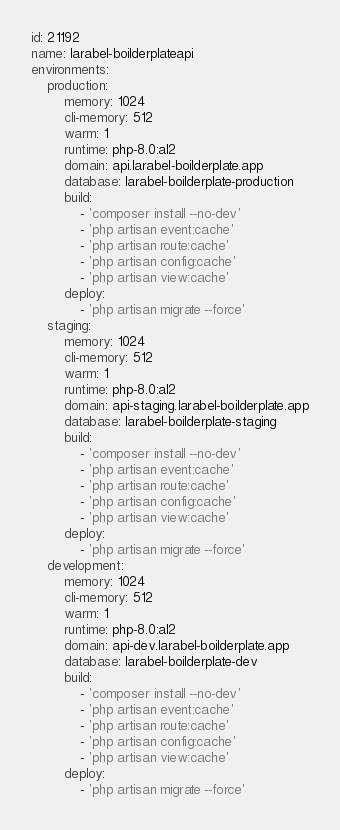<code> <loc_0><loc_0><loc_500><loc_500><_YAML_>id: 21192
name: larabel-boilderplateapi
environments:
    production:
        memory: 1024
        cli-memory: 512
        warm: 1
        runtime: php-8.0:al2
        domain: api.larabel-boilderplate.app
        database: larabel-boilderplate-production
        build:
            - 'composer install --no-dev'
            - 'php artisan event:cache'
            - 'php artisan route:cache'
            - 'php artisan config:cache'
            - 'php artisan view:cache'
        deploy:
            - 'php artisan migrate --force'
    staging:
        memory: 1024
        cli-memory: 512
        warm: 1
        runtime: php-8.0:al2
        domain: api-staging.larabel-boilderplate.app
        database: larabel-boilderplate-staging
        build:
            - 'composer install --no-dev'
            - 'php artisan event:cache'
            - 'php artisan route:cache'
            - 'php artisan config:cache'
            - 'php artisan view:cache'
        deploy:
            - 'php artisan migrate --force'
    development:
        memory: 1024
        cli-memory: 512
        warm: 1
        runtime: php-8.0:al2
        domain: api-dev.larabel-boilderplate.app
        database: larabel-boilderplate-dev
        build:
            - 'composer install --no-dev'
            - 'php artisan event:cache'
            - 'php artisan route:cache'
            - 'php artisan config:cache'
            - 'php artisan view:cache'
        deploy:
            - 'php artisan migrate --force'
</code> 